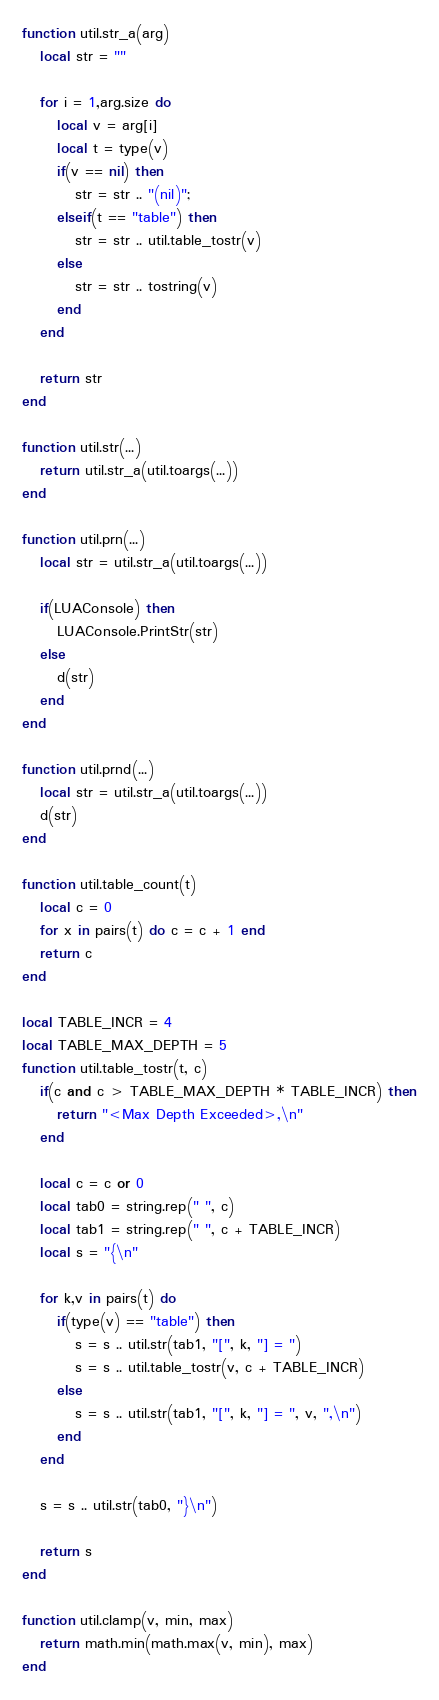Convert code to text. <code><loc_0><loc_0><loc_500><loc_500><_Lua_>function util.str_a(arg)
   local str = ""

   for i = 1,arg.size do
      local v = arg[i]
      local t = type(v)
      if(v == nil) then
         str = str .. "(nil)";
      elseif(t == "table") then
         str = str .. util.table_tostr(v)
      else
         str = str .. tostring(v)
      end
   end

   return str
end

function util.str(...)
   return util.str_a(util.toargs(...))
end

function util.prn(...)
   local str = util.str_a(util.toargs(...))

   if(LUAConsole) then
      LUAConsole.PrintStr(str)
   else
      d(str)
   end
end

function util.prnd(...)
   local str = util.str_a(util.toargs(...))
   d(str)
end

function util.table_count(t)
   local c = 0
   for x in pairs(t) do c = c + 1 end
   return c
end

local TABLE_INCR = 4
local TABLE_MAX_DEPTH = 5
function util.table_tostr(t, c)
   if(c and c > TABLE_MAX_DEPTH * TABLE_INCR) then
      return "<Max Depth Exceeded>,\n"
   end

   local c = c or 0
   local tab0 = string.rep(" ", c)
   local tab1 = string.rep(" ", c + TABLE_INCR)
   local s = "{\n"

   for k,v in pairs(t) do
      if(type(v) == "table") then
         s = s .. util.str(tab1, "[", k, "] = ")
         s = s .. util.table_tostr(v, c + TABLE_INCR)
      else
         s = s .. util.str(tab1, "[", k, "] = ", v, ",\n")
      end
   end

   s = s .. util.str(tab0, "}\n")

   return s
end

function util.clamp(v, min, max)
   return math.min(math.max(v, min), max)
end
</code> 